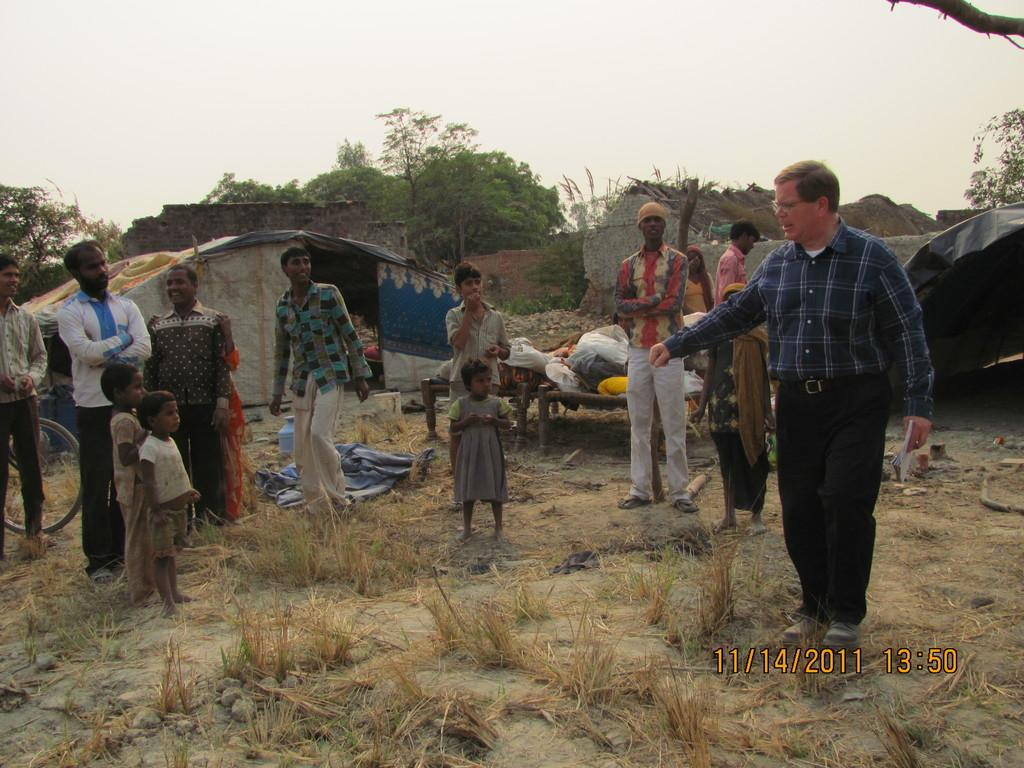What type of vegetation can be seen in the image? There is dry grass in the image. Who or what is present in the image? There are people and houses in the image. What other natural elements can be seen in the image? There are trees in the image. What is visible at the top of the image? The sky is visible at the top of the image. What is the name of the tree that is blocking the view of the houses in the image? There is no tree blocking the view of the houses in the image, and therefore no name can be given. How does the feeling of shame manifest in the image? There is no indication of shame or any emotions in the image. 